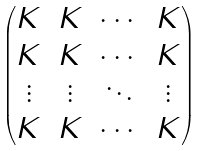Convert formula to latex. <formula><loc_0><loc_0><loc_500><loc_500>\begin{pmatrix} K & K & \cdots & K \\ K & K & \cdots & K \\ \vdots & \vdots & \ddots & \vdots \\ K & K & \cdots & K \end{pmatrix}</formula> 